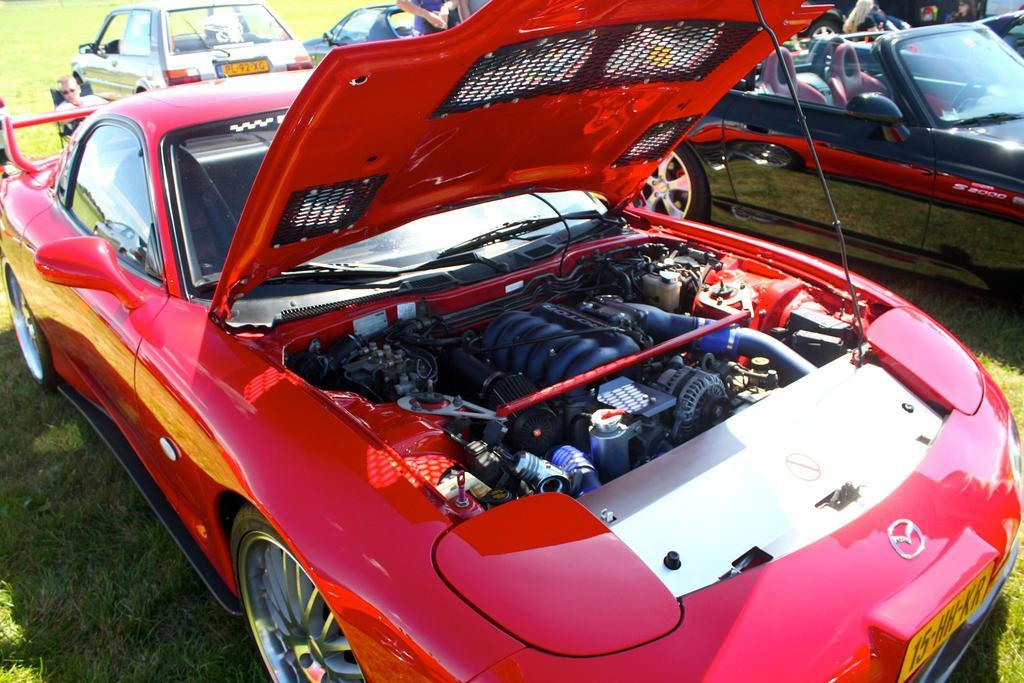What type of vehicles are on the grass in the image? There are cars on the grass in the image. Can you describe the person in the image? There is a person sitting on a chair in the image. Where is the person located in the image? The person is at the back side of the image. What type of quilt is being used to play in the image? There is no quilt or playing activity present in the image. 